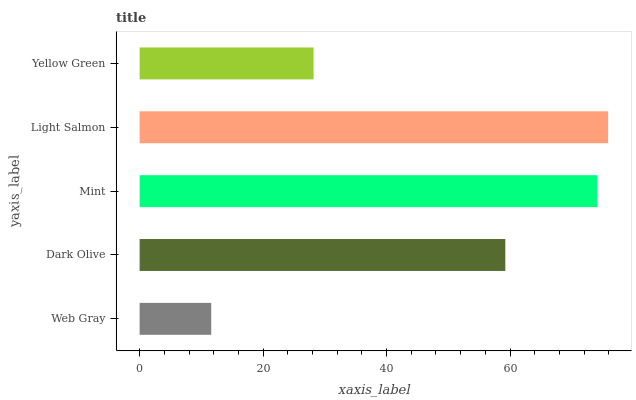Is Web Gray the minimum?
Answer yes or no. Yes. Is Light Salmon the maximum?
Answer yes or no. Yes. Is Dark Olive the minimum?
Answer yes or no. No. Is Dark Olive the maximum?
Answer yes or no. No. Is Dark Olive greater than Web Gray?
Answer yes or no. Yes. Is Web Gray less than Dark Olive?
Answer yes or no. Yes. Is Web Gray greater than Dark Olive?
Answer yes or no. No. Is Dark Olive less than Web Gray?
Answer yes or no. No. Is Dark Olive the high median?
Answer yes or no. Yes. Is Dark Olive the low median?
Answer yes or no. Yes. Is Web Gray the high median?
Answer yes or no. No. Is Mint the low median?
Answer yes or no. No. 